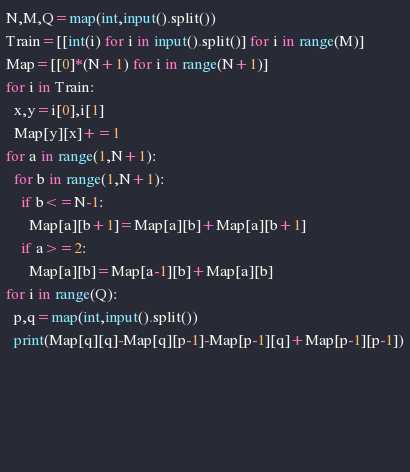Convert code to text. <code><loc_0><loc_0><loc_500><loc_500><_Python_>N,M,Q=map(int,input().split())
Train=[[int(i) for i in input().split()] for i in range(M)]
Map=[[0]*(N+1) for i in range(N+1)]
for i in Train:
  x,y=i[0],i[1]
  Map[y][x]+=1
for a in range(1,N+1):
  for b in range(1,N+1):
    if b<=N-1:
      Map[a][b+1]=Map[a][b]+Map[a][b+1]
    if a>=2:
      Map[a][b]=Map[a-1][b]+Map[a][b]
for i in range(Q):
  p,q=map(int,input().split())
  print(Map[q][q]-Map[q][p-1]-Map[p-1][q]+Map[p-1][p-1])

  


    </code> 